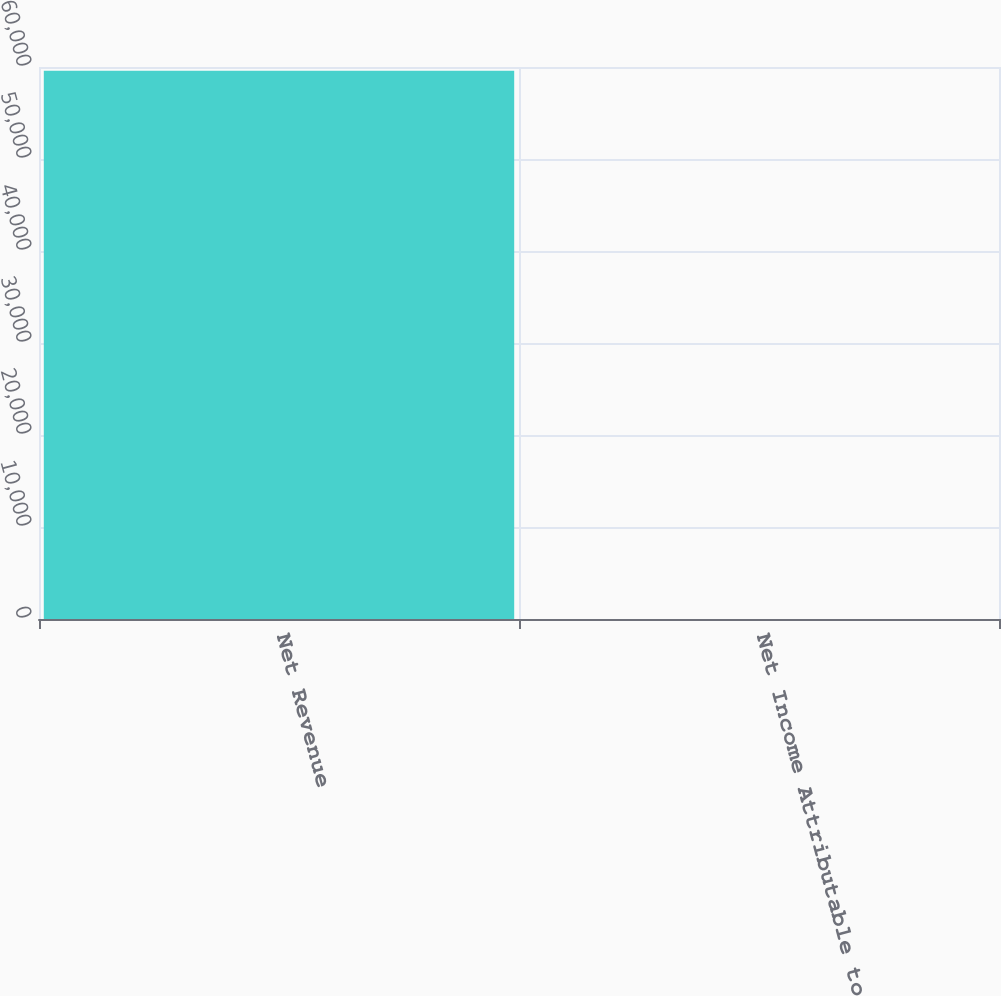Convert chart. <chart><loc_0><loc_0><loc_500><loc_500><bar_chart><fcel>Net Revenue<fcel>Net Income Attributable to<nl><fcel>59582<fcel>3.6<nl></chart> 